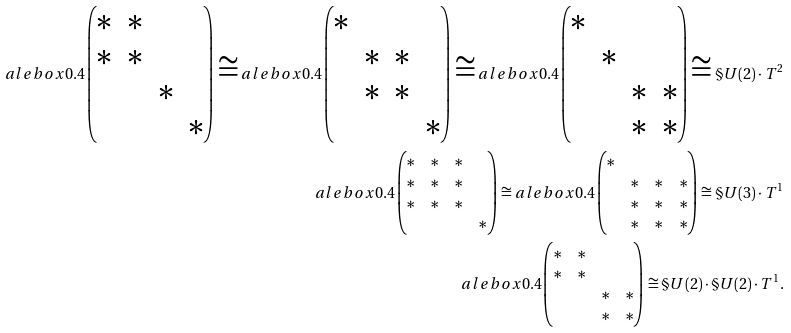<formula> <loc_0><loc_0><loc_500><loc_500>a l e b o x { 0 . 4 } { \begin{pmatrix} * & * & & \\ { * } & * & & \\ & & * & \\ & & & * \end{pmatrix} } \cong a l e b o x { 0 . 4 } { \begin{pmatrix} * & & & \\ & * & * & \\ & * & * & \\ & & & * \end{pmatrix} } \cong a l e b o x { 0 . 4 } { \begin{pmatrix} * & & & \\ & * & & \\ & & * & * \\ & & * & * \end{pmatrix} } \cong \S U ( 2 ) \cdot T ^ { 2 } \\ a l e b o x { 0 . 4 } { \begin{pmatrix} * & * & * & \\ { * } & * & * & \\ { * } & * & * & \\ & & & * \end{pmatrix} } \cong a l e b o x { 0 . 4 } { \begin{pmatrix} * & & & \\ & * & * & * \\ & * & * & * \\ & * & * & * \end{pmatrix} } \cong \S U ( 3 ) \cdot T ^ { 1 } \\ a l e b o x { 0 . 4 } { \begin{pmatrix} * & * & & \\ { * } & * & & \\ & & * & * \\ & & * & * \end{pmatrix} } \cong \S U ( 2 ) \cdot \S U ( 2 ) \cdot T ^ { 1 } .</formula> 